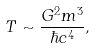<formula> <loc_0><loc_0><loc_500><loc_500>T \sim \frac { G ^ { 2 } m ^ { 3 } } { \hbar { c } ^ { 4 } } ,</formula> 